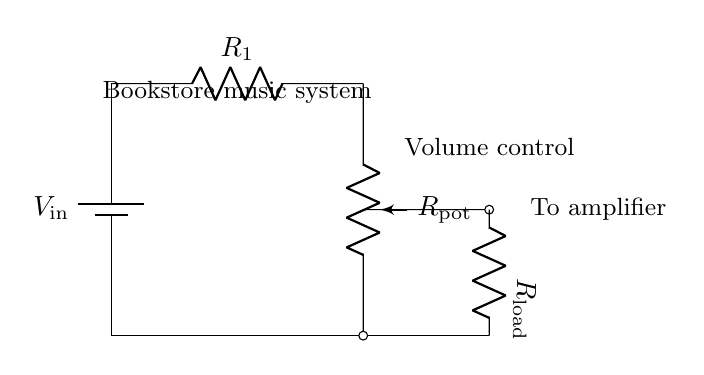What is the input voltage in the circuit? The input voltage is labeled as \( V_\text{in} \) in the circuit diagram. There isn't a specific numerical value given, but it represents the voltage supplied to the circuit.
Answer: V_in What component is used for volume control? The component used for volume control is labeled \( R_\text{pot} \), which represents a potentiometer. This component allows for variable resistance, thus adjusting the volume.
Answer: R_pot What is the function of \( R_1 \)? \( R_1 \) is a resistor that is part of the voltage divider. Its value influences the voltage drop across the potentiometer and subsequently affects the volume level.
Answer: Resistor Which component is connected to the amplifier? The load resistor labeled \( R_\text{load} \) is connected to the amplifier. This is the component that receives the output voltage after the potentiometer, affecting the signal fed into the amplifier.
Answer: R_load How does a potentiometer change the output voltage? The potentiometer, when adjusted, changes its resistance, which in turn changes the voltage division between \( R_1 \) and \( R_\text{pot} \). This results in a different output voltage to the load, allowing control over the amplitude of the sound.
Answer: By adjusting resistance What kind of circuit is this? This is a voltage divider circuit. Voltage dividers are used to reduce voltage, and in this case, it is applied to control the volume of the background music system through the potentiometer.
Answer: Voltage divider What would happen if \( R_1 \) is increased? Increasing \( R_1 \) would increase the total resistance in the voltage divider, lowering the output voltage across the potentiometer. This would result in a lower volume for the background music.
Answer: Lower volume 